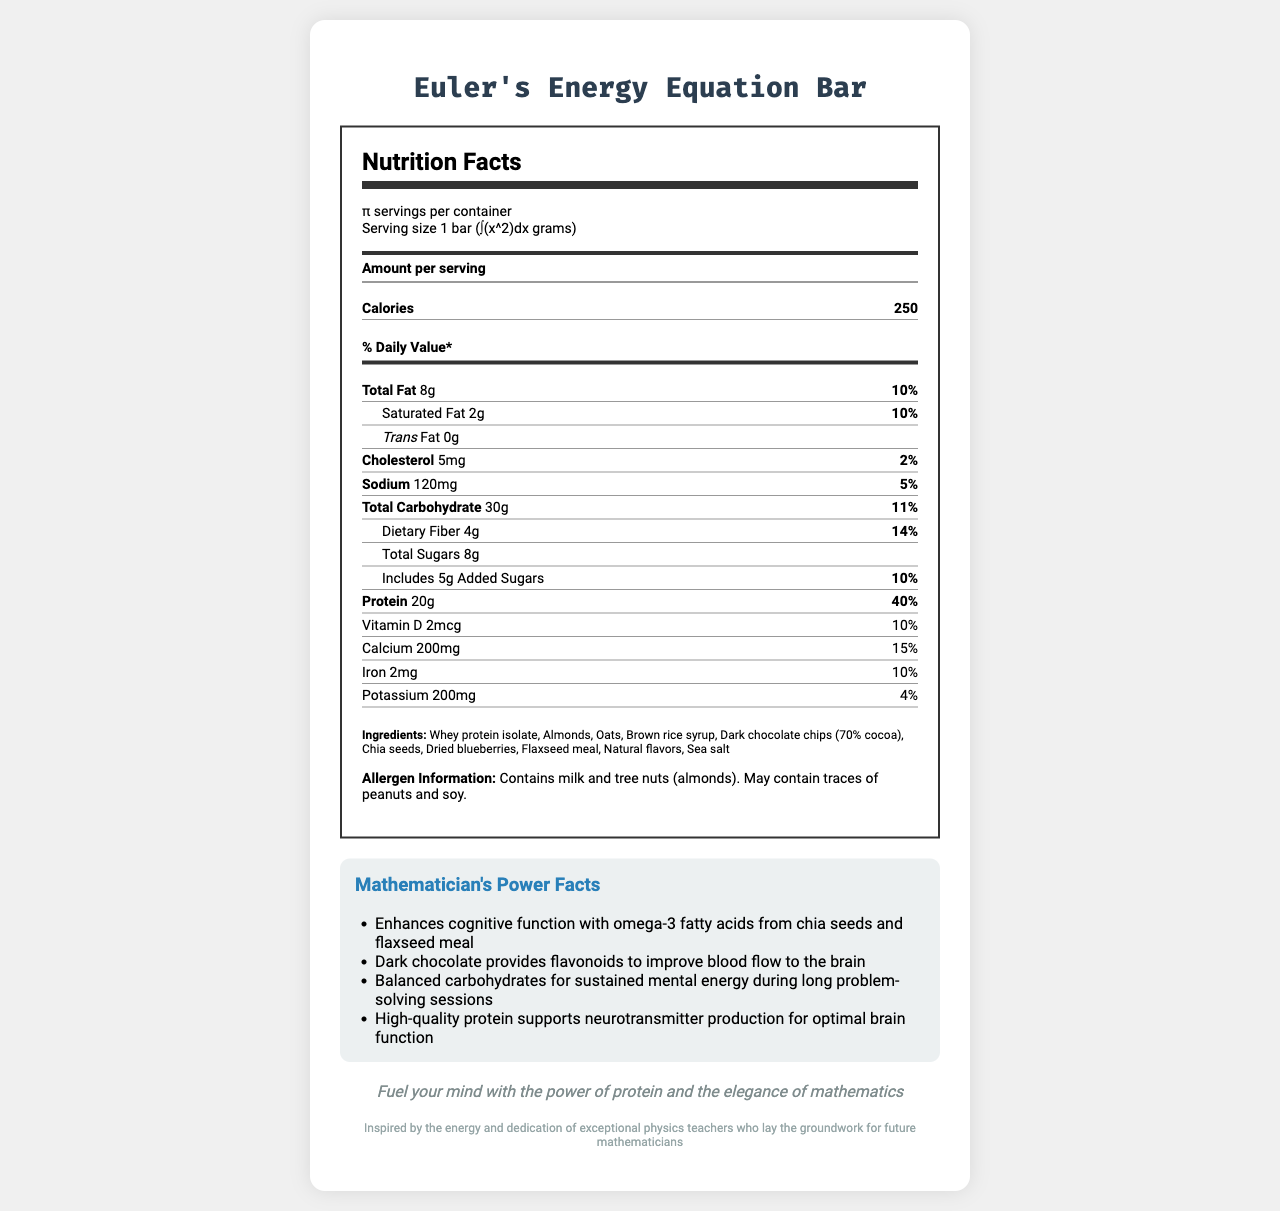What is the product name of the energy bar? The product name is displayed prominently at the top of the document.
Answer: Euler's Energy Equation Bar What is the serving size of the energy bar in mathematical notation? The serving size is mentioned in the serving information section as "1 bar (∫(x^2)dx grams)".
Answer: 1 bar (∫(x^2)dx grams) How many servings are there per container? The document specifies that there are π servings per container.
Answer: π How many grams of protein does one serving contain? The amount of protein per serving is listed under the nutrient section as "20g".
Answer: 20g What percentage of the daily value of calcium does the energy bar provide? The document lists the daily value percentage for calcium as 15%.
Answer: 15% What is the total amount of fat in one serving? The total amount of fat is listed in the nutrient section as "8g".
Answer: 8g Which ingredient in the energy bar provides omega-3 fatty acids? A. Whey protein isolate B. Almonds C. Chia seeds D. Flaxseed meal Both chia seeds and flaxseed meal are listed under "Mathematician's Power Facts" as sources of omega-3 fatty acids.
Answer: C and D What type of chocolate is used in the energy bar? A. Milk chocolate B. Dark chocolate C. White chocolate The ingredients list specifies "Dark chocolate chips (70% cocoa)".
Answer: B Does the bar contain any trans fat? The nutrient section explicitly states "Trans Fat 0g".
Answer: No Summarize the main information provided in the document. The summary captures the product name, nutritional details, ingredients, benefits, and additional contextual information, offering a complete view of the document.
Answer: The document presents the nutrition facts for Euler's Energy Equation Bar. This high-protein energy bar is tailored for mathematicians with a serving size expressed in mathematical notation. Each serving provides 250 calories, 8g of total fat, 20g of protein, and other nutrients such as calcium, iron, and dietary fiber. The bar consists of ingredients like whey protein isolate, almonds, and flaxseed meal and highlights cognitive and physical benefits through its composition. Several mathematicians' power facts and the allergen information are also provided. An inspirational tagline and a tribute to physics teachers round out the support information provided for future mathematicians. Are omega-3 fatty acids mentioned in the document? The document lists omega-3 fatty acids under the "Mathematician's Power Facts" section.
Answer: Yes How much dietary fiber is in one serving? The nutrient facts specify "Dietary Fiber 4g".
Answer: 4g What is the tribute mentioned in the document? The tribute is stated at the end of the document, acknowledging the role of physics teachers.
Answer: Inspired by the energy and dedication of exceptional physics teachers who lay the groundwork for future mathematicians Does the energy bar contain peanuts? The allergen information indicates the possibility of traces of peanuts.
Answer: May contain traces of peanuts What are the total sugars per serving? The document specifies the total sugars as "8g".
Answer: 8g What is the tagline of Euler's Energy Equation Bar? The tagline is prominently displayed towards the end of the document.
Answer: Fuel your mind with the power of protein and the elegance of mathematics Can the exact weight in grams of one energy bar be determined from the document? The serving size is given in mathematical notation (∫(x^2)dx grams), and without additional information or specific bounds for integration, the exact weight in grams cannot be determined.
Answer: Not enough information 